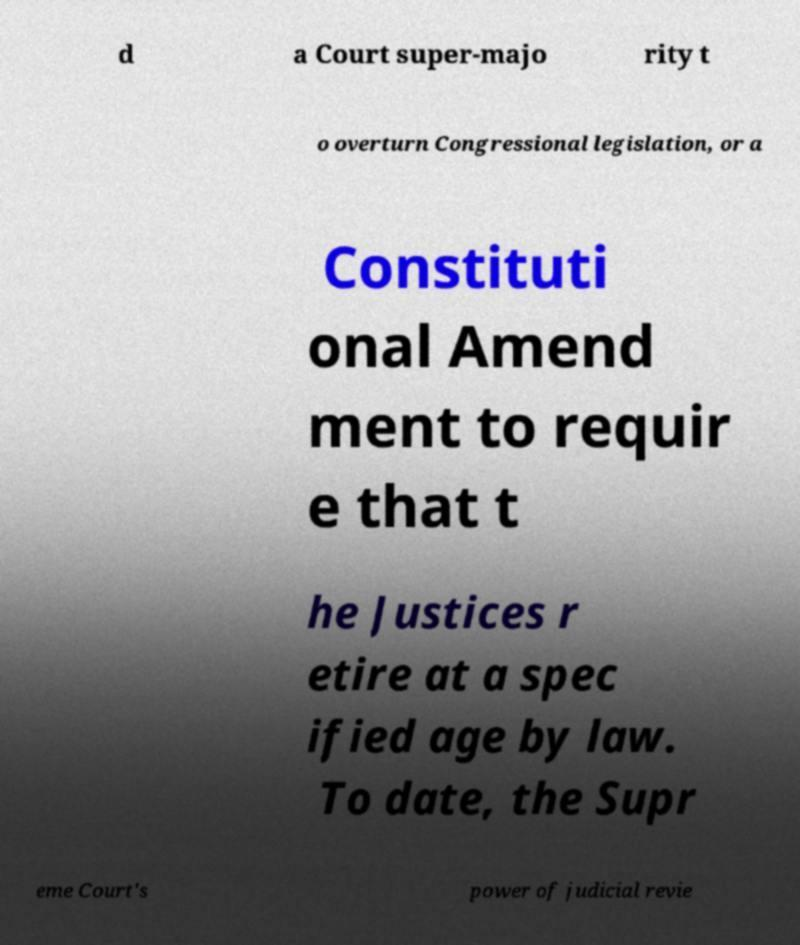There's text embedded in this image that I need extracted. Can you transcribe it verbatim? d a Court super-majo rity t o overturn Congressional legislation, or a Constituti onal Amend ment to requir e that t he Justices r etire at a spec ified age by law. To date, the Supr eme Court's power of judicial revie 